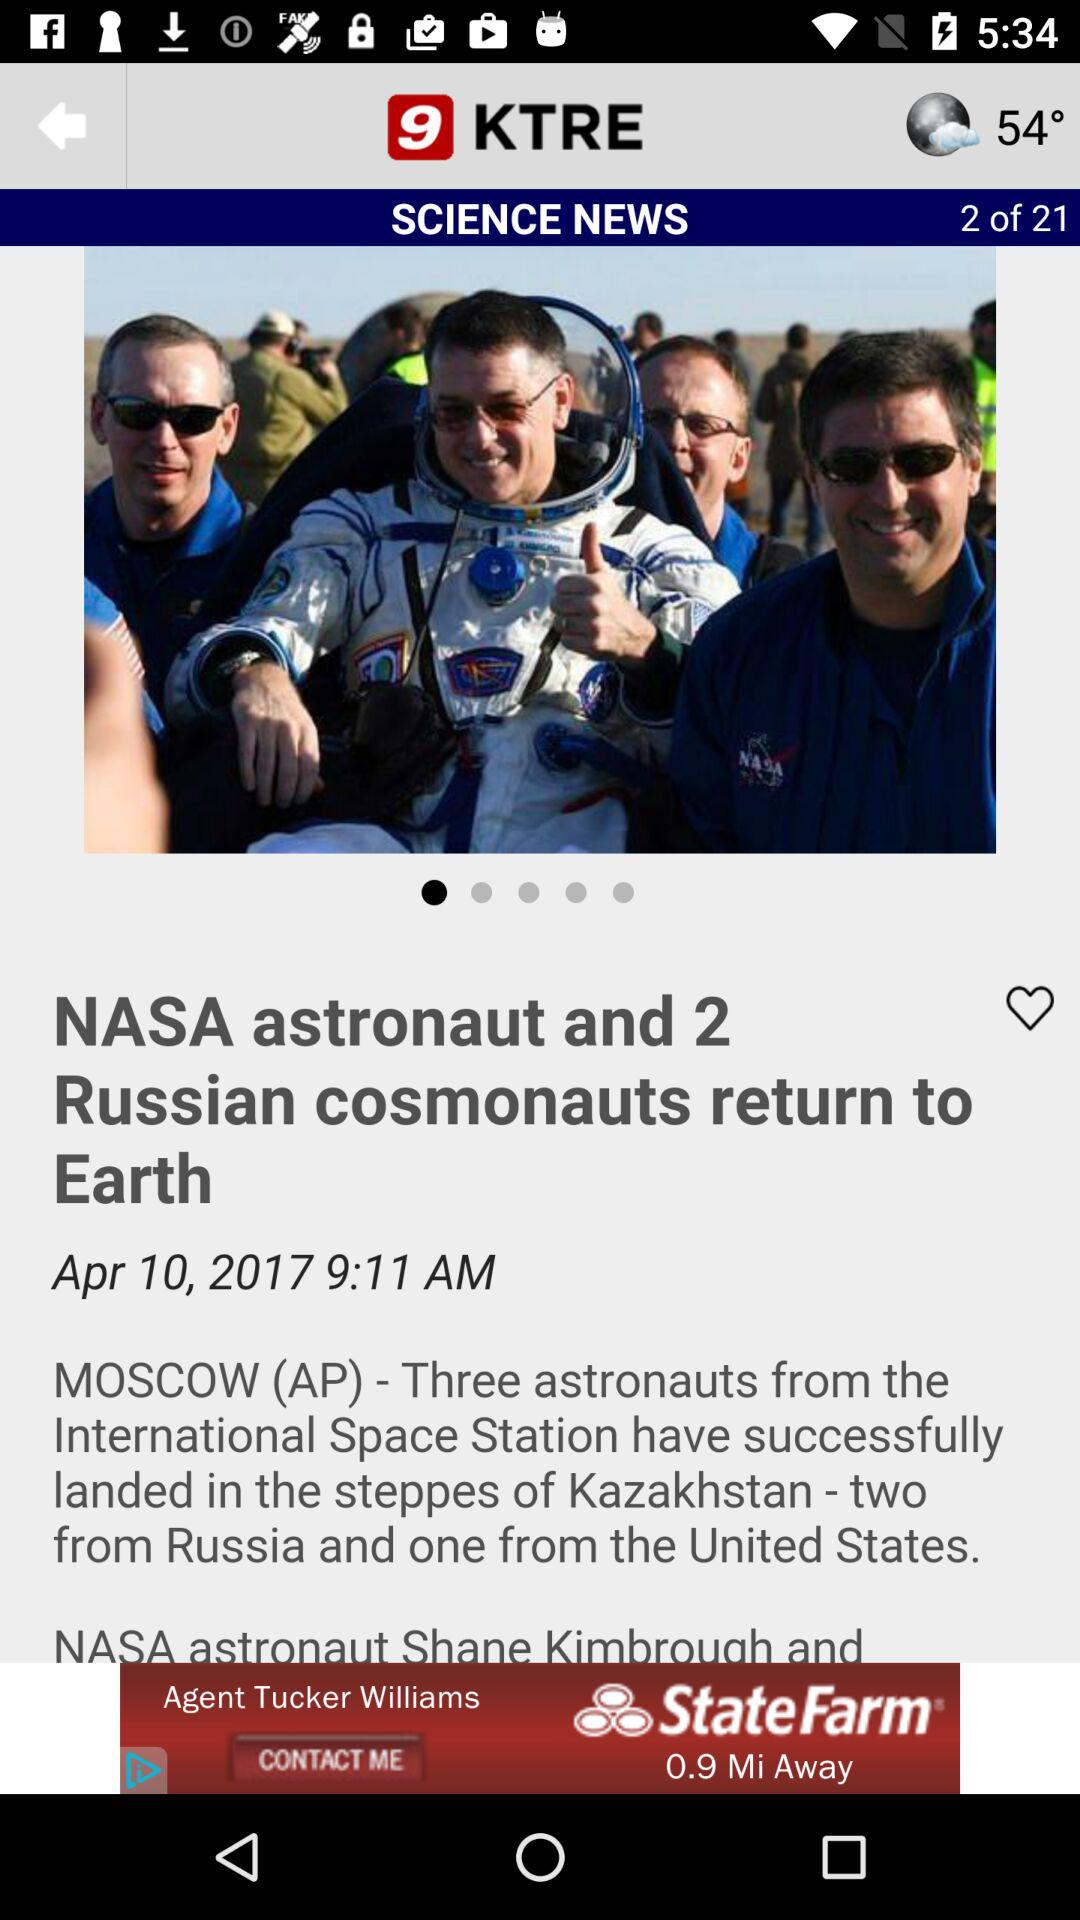What is the temperature? The temperature is 54°. 